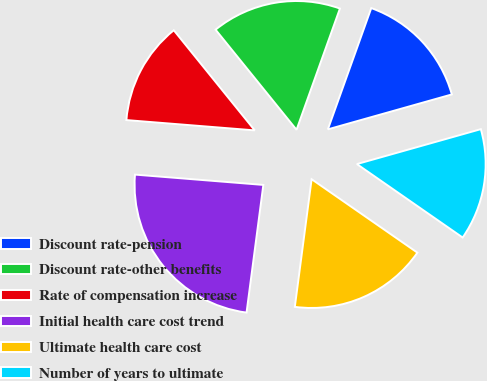<chart> <loc_0><loc_0><loc_500><loc_500><pie_chart><fcel>Discount rate-pension<fcel>Discount rate-other benefits<fcel>Rate of compensation increase<fcel>Initial health care cost trend<fcel>Ultimate health care cost<fcel>Number of years to ultimate<nl><fcel>15.16%<fcel>16.29%<fcel>12.9%<fcel>24.19%<fcel>17.42%<fcel>14.03%<nl></chart> 